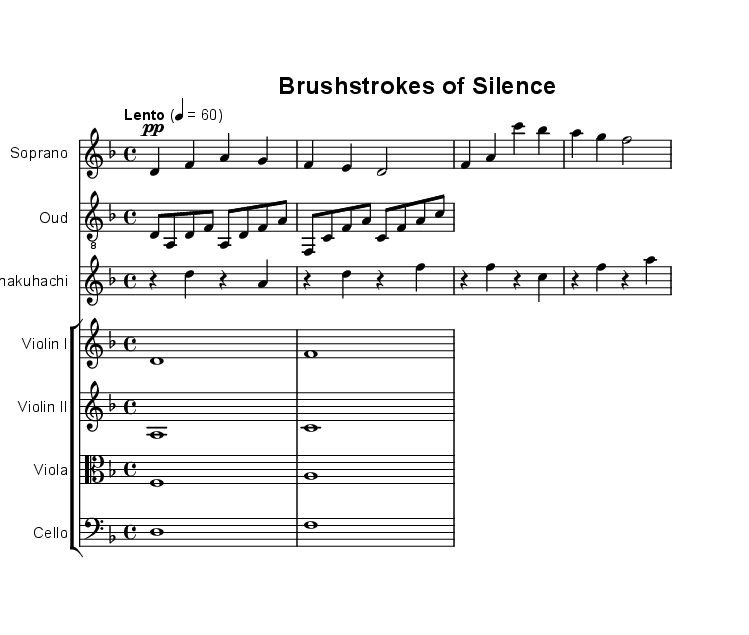What is the key signature of this music? The key signature is D minor, which has one flat (B flat).
Answer: D minor What is the time signature of this music? The time signature is 4/4, indicating four beats per measure.
Answer: 4/4 What is the tempo marking for the piece? The tempo marking is "Lento," which indicates a slow pace, corresponding to a quarter note equals 60 beats per minute.
Answer: Lento How many measures are in the soprano part? The soprano part contains 4 measures, as shown by the notation and line breaks.
Answer: 4 Which instrument has a clef of treble 8? The instrument with a clef of treble 8 is the Oud, which is transposed down an octave for playback.
Answer: Oud Which instruments are included in the string section? The string section includes Violin I, Violin II, Viola, and Cello, as indicated by their individual staves grouped together.
Answer: Violin I, Violin II, Viola, Cello What forms the texture of the opera in this excerpt? The texture of the opera is formed by the combination of voice (soprano), oud, shakuhachi, and string instruments, creating polyphonic interaction.
Answer: Soprano, Oud, Shakuhachi, Strings 